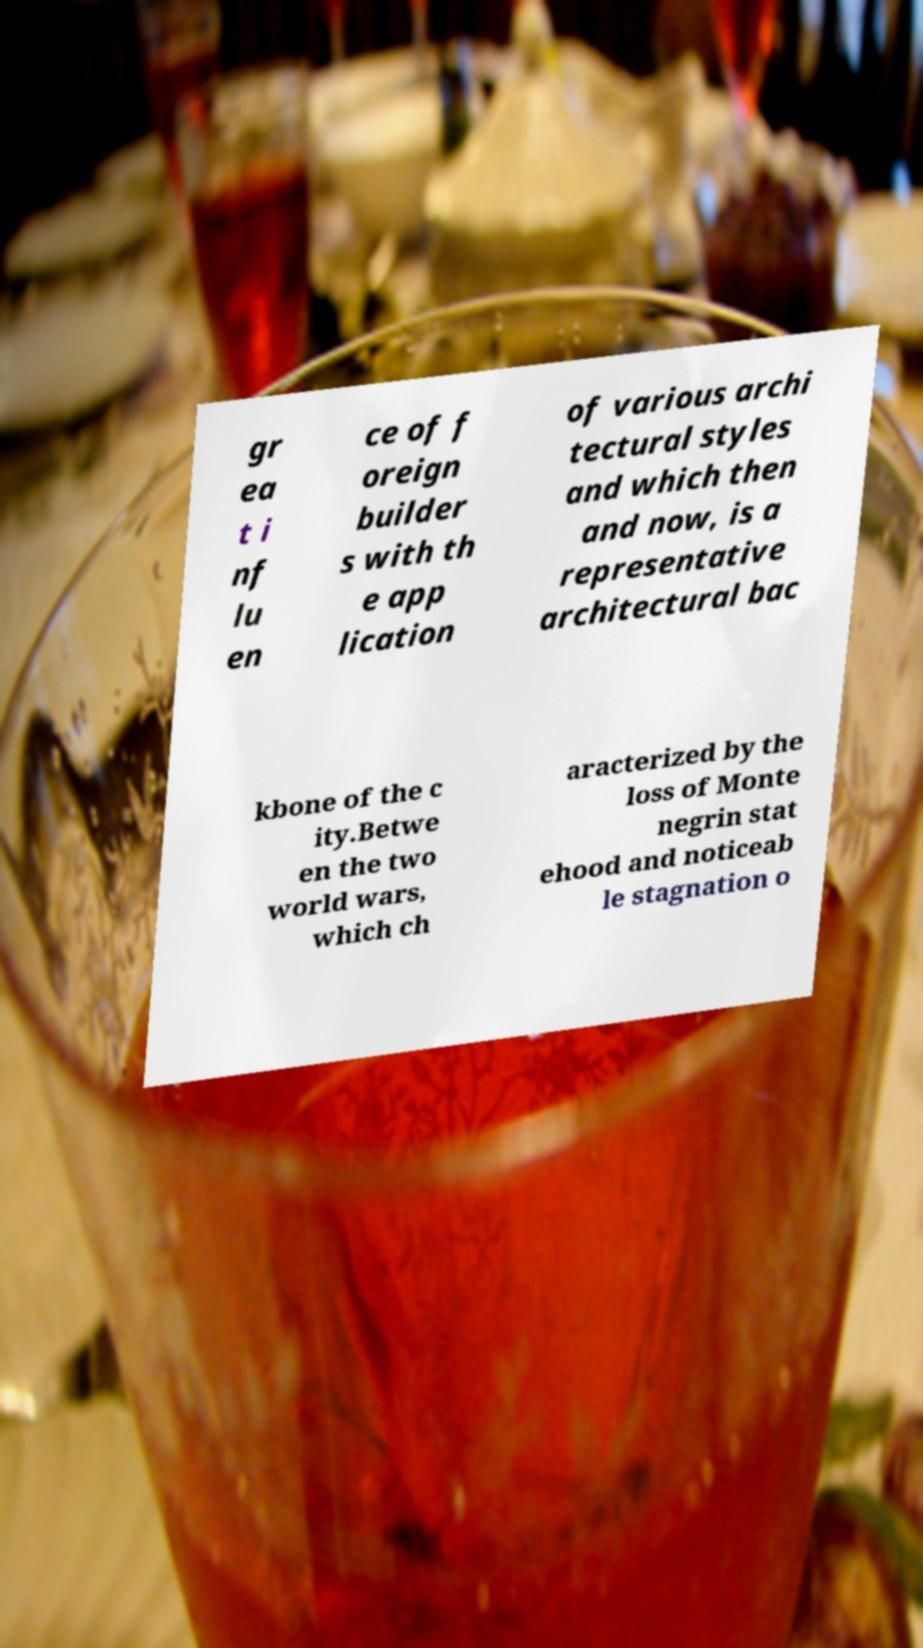I need the written content from this picture converted into text. Can you do that? gr ea t i nf lu en ce of f oreign builder s with th e app lication of various archi tectural styles and which then and now, is a representative architectural bac kbone of the c ity.Betwe en the two world wars, which ch aracterized by the loss of Monte negrin stat ehood and noticeab le stagnation o 